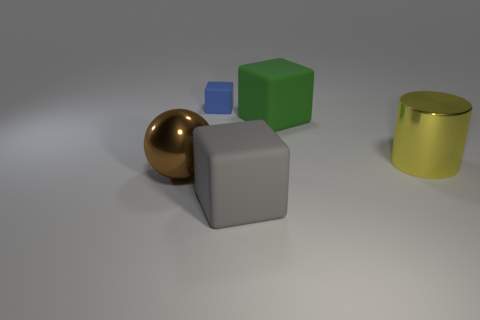Add 3 small red shiny balls. How many objects exist? 8 Subtract all blocks. How many objects are left? 2 Subtract all blue matte cubes. Subtract all matte things. How many objects are left? 1 Add 1 large green matte blocks. How many large green matte blocks are left? 2 Add 1 yellow shiny cylinders. How many yellow shiny cylinders exist? 2 Subtract 0 red balls. How many objects are left? 5 